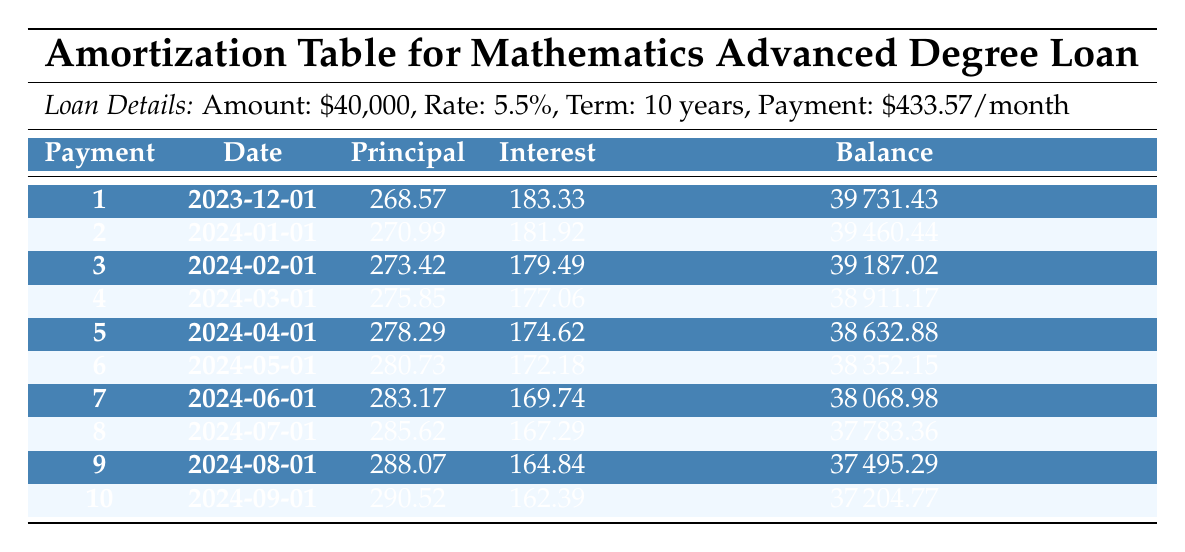What is the principal payment in the first month? The principal payment for the first month is listed in the table under the Principal column for Payment number 1, which is 268.57.
Answer: 268.57 What is the total interest payment made in the first three months? The interest payments for the first three months are 183.33 (month 1) + 181.92 (month 2) + 179.49 (month 3) = 544.74.
Answer: 544.74 Is the remaining balance after the second payment less than $39,500? The remaining balance after the second payment is 39460.44, which is greater than 39,500. Therefore, this statement is false.
Answer: No What is the average principal payment made in the first ten months? The principal payments for the first ten months are: 268.57, 270.99, 273.42, 275.85, 278.29, 280.73, 283.17, 285.62, 288.07, and 290.52. Summing these gives a total principal payment of 2,629.00. Dividing this by 10, the average principal payment is 262.90.
Answer: 262.90 What is the change in remaining balance from the first to the fifth payment? The remaining balance after the first payment is 39731.43 and after the fifth payment is 38632.88. The change in remaining balance is 39731.43 - 38632.88 = 1,098.55.
Answer: 1098.55 Which payment number has the highest interest payment? The interest payments from the first ten payments are: 183.33, 181.92, 179.49, 177.06, 174.62, 172.18, 169.74, 167.29, 164.84, and 162.39. The highest interest payment is for the first payment, which is 183.33.
Answer: 1 What is the total amount of principal paid after the first four payments? The principal payments after the first four payments are: 268.57 (month 1) + 270.99 (month 2) + 273.42 (month 3) + 275.85 (month 4) = 1,088.83.
Answer: 1088.83 Is the remaining balance after the eighth payment more than $37,500? The remaining balance after the eighth payment is 37783.36, which is greater than 37,500. Therefore, this statement is true.
Answer: Yes What is the difference between total payments made in the first two months and the total payments made in the last two months? The total payments made in the first two months are 433.57 + 433.57 = 867.14. The total payments made in the last two months are 433.57 + 433.57 = 867.14. The difference is 867.14 - 867.14 = 0.
Answer: 0 